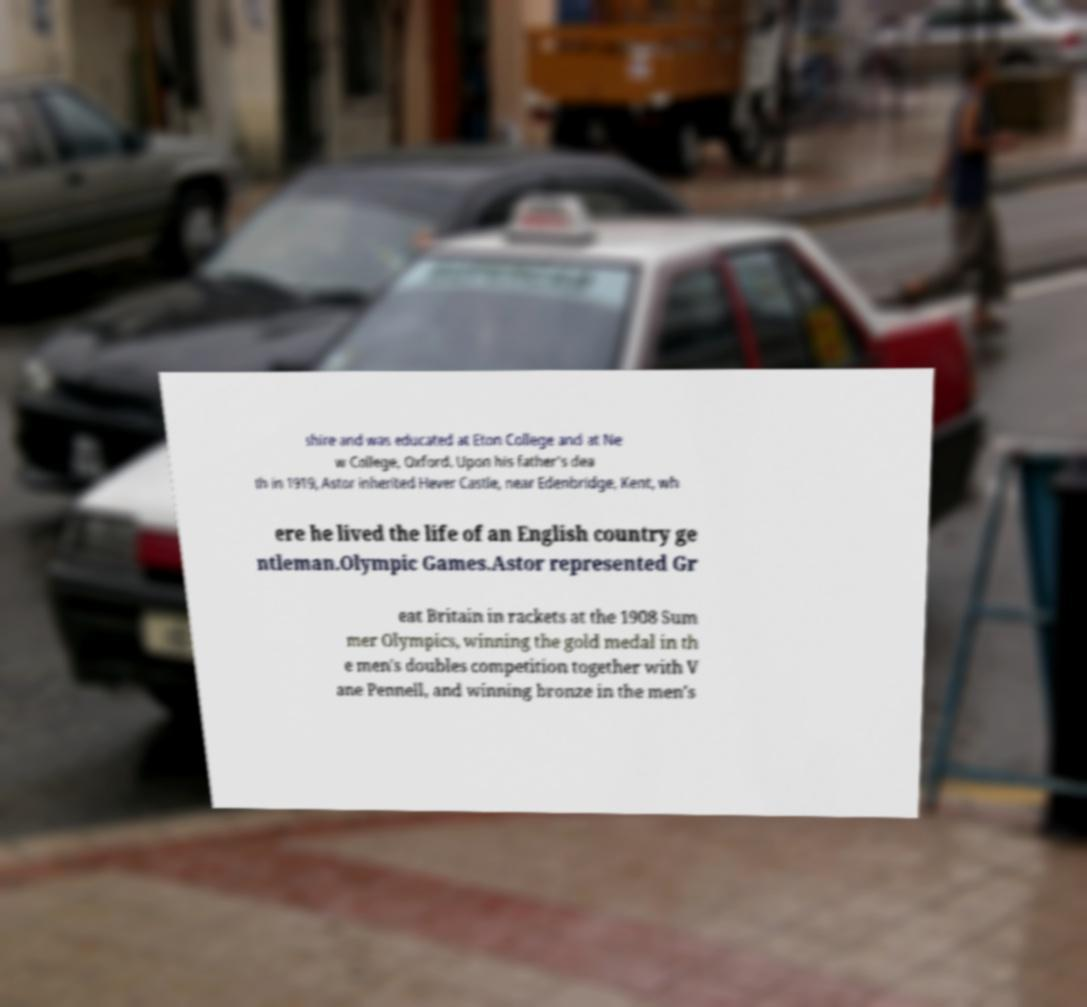Please identify and transcribe the text found in this image. shire and was educated at Eton College and at Ne w College, Oxford. Upon his father's dea th in 1919, Astor inherited Hever Castle, near Edenbridge, Kent, wh ere he lived the life of an English country ge ntleman.Olympic Games.Astor represented Gr eat Britain in rackets at the 1908 Sum mer Olympics, winning the gold medal in th e men's doubles competition together with V ane Pennell, and winning bronze in the men's 